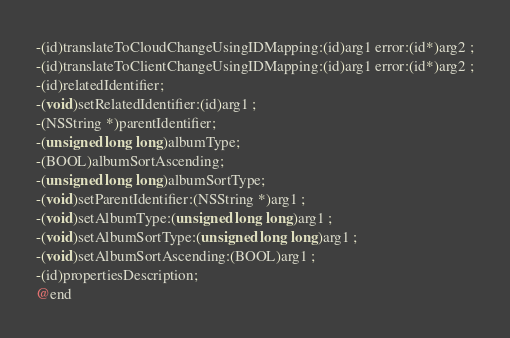Convert code to text. <code><loc_0><loc_0><loc_500><loc_500><_C_>-(id)translateToCloudChangeUsingIDMapping:(id)arg1 error:(id*)arg2 ;
-(id)translateToClientChangeUsingIDMapping:(id)arg1 error:(id*)arg2 ;
-(id)relatedIdentifier;
-(void)setRelatedIdentifier:(id)arg1 ;
-(NSString *)parentIdentifier;
-(unsigned long long)albumType;
-(BOOL)albumSortAscending;
-(unsigned long long)albumSortType;
-(void)setParentIdentifier:(NSString *)arg1 ;
-(void)setAlbumType:(unsigned long long)arg1 ;
-(void)setAlbumSortType:(unsigned long long)arg1 ;
-(void)setAlbumSortAscending:(BOOL)arg1 ;
-(id)propertiesDescription;
@end

</code> 